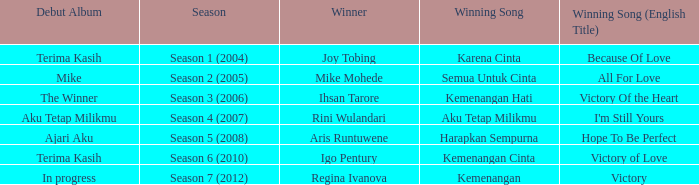Which English winning song had the winner aris runtuwene? Hope To Be Perfect. 